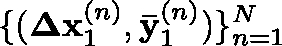<formula> <loc_0><loc_0><loc_500><loc_500>\{ ( { \Delta x _ { 1 } ^ { ( n ) } , \bar { y } _ { 1 } ^ { ( n ) } } ) \} _ { n = 1 } ^ { N }</formula> 